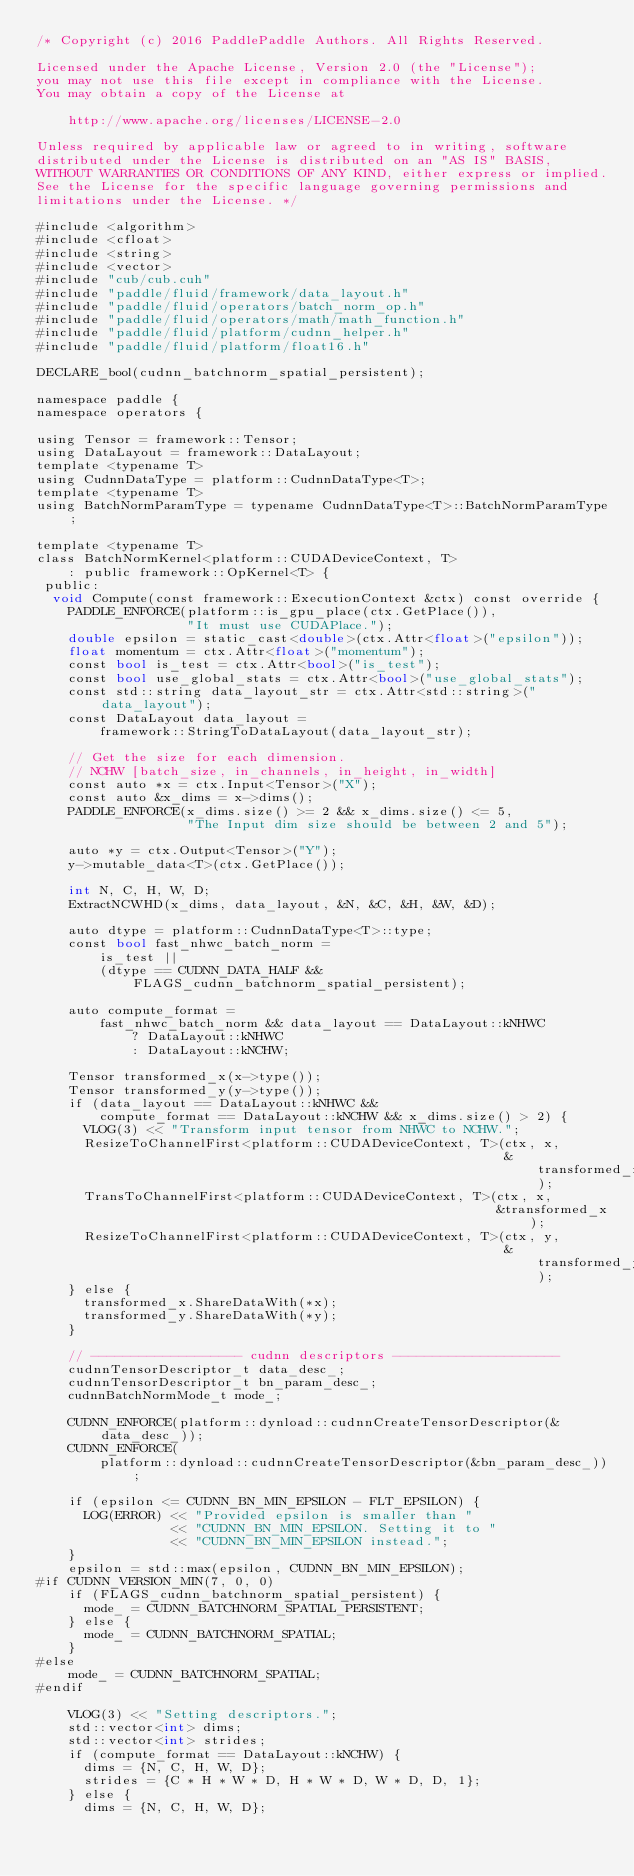<code> <loc_0><loc_0><loc_500><loc_500><_Cuda_>/* Copyright (c) 2016 PaddlePaddle Authors. All Rights Reserved.

Licensed under the Apache License, Version 2.0 (the "License");
you may not use this file except in compliance with the License.
You may obtain a copy of the License at

    http://www.apache.org/licenses/LICENSE-2.0

Unless required by applicable law or agreed to in writing, software
distributed under the License is distributed on an "AS IS" BASIS,
WITHOUT WARRANTIES OR CONDITIONS OF ANY KIND, either express or implied.
See the License for the specific language governing permissions and
limitations under the License. */

#include <algorithm>
#include <cfloat>
#include <string>
#include <vector>
#include "cub/cub.cuh"
#include "paddle/fluid/framework/data_layout.h"
#include "paddle/fluid/operators/batch_norm_op.h"
#include "paddle/fluid/operators/math/math_function.h"
#include "paddle/fluid/platform/cudnn_helper.h"
#include "paddle/fluid/platform/float16.h"

DECLARE_bool(cudnn_batchnorm_spatial_persistent);

namespace paddle {
namespace operators {

using Tensor = framework::Tensor;
using DataLayout = framework::DataLayout;
template <typename T>
using CudnnDataType = platform::CudnnDataType<T>;
template <typename T>
using BatchNormParamType = typename CudnnDataType<T>::BatchNormParamType;

template <typename T>
class BatchNormKernel<platform::CUDADeviceContext, T>
    : public framework::OpKernel<T> {
 public:
  void Compute(const framework::ExecutionContext &ctx) const override {
    PADDLE_ENFORCE(platform::is_gpu_place(ctx.GetPlace()),
                   "It must use CUDAPlace.");
    double epsilon = static_cast<double>(ctx.Attr<float>("epsilon"));
    float momentum = ctx.Attr<float>("momentum");
    const bool is_test = ctx.Attr<bool>("is_test");
    const bool use_global_stats = ctx.Attr<bool>("use_global_stats");
    const std::string data_layout_str = ctx.Attr<std::string>("data_layout");
    const DataLayout data_layout =
        framework::StringToDataLayout(data_layout_str);

    // Get the size for each dimension.
    // NCHW [batch_size, in_channels, in_height, in_width]
    const auto *x = ctx.Input<Tensor>("X");
    const auto &x_dims = x->dims();
    PADDLE_ENFORCE(x_dims.size() >= 2 && x_dims.size() <= 5,
                   "The Input dim size should be between 2 and 5");

    auto *y = ctx.Output<Tensor>("Y");
    y->mutable_data<T>(ctx.GetPlace());

    int N, C, H, W, D;
    ExtractNCWHD(x_dims, data_layout, &N, &C, &H, &W, &D);

    auto dtype = platform::CudnnDataType<T>::type;
    const bool fast_nhwc_batch_norm =
        is_test ||
        (dtype == CUDNN_DATA_HALF && FLAGS_cudnn_batchnorm_spatial_persistent);

    auto compute_format =
        fast_nhwc_batch_norm && data_layout == DataLayout::kNHWC
            ? DataLayout::kNHWC
            : DataLayout::kNCHW;

    Tensor transformed_x(x->type());
    Tensor transformed_y(y->type());
    if (data_layout == DataLayout::kNHWC &&
        compute_format == DataLayout::kNCHW && x_dims.size() > 2) {
      VLOG(3) << "Transform input tensor from NHWC to NCHW.";
      ResizeToChannelFirst<platform::CUDADeviceContext, T>(ctx, x,
                                                           &transformed_x);
      TransToChannelFirst<platform::CUDADeviceContext, T>(ctx, x,
                                                          &transformed_x);
      ResizeToChannelFirst<platform::CUDADeviceContext, T>(ctx, y,
                                                           &transformed_y);
    } else {
      transformed_x.ShareDataWith(*x);
      transformed_y.ShareDataWith(*y);
    }

    // ------------------- cudnn descriptors ---------------------
    cudnnTensorDescriptor_t data_desc_;
    cudnnTensorDescriptor_t bn_param_desc_;
    cudnnBatchNormMode_t mode_;

    CUDNN_ENFORCE(platform::dynload::cudnnCreateTensorDescriptor(&data_desc_));
    CUDNN_ENFORCE(
        platform::dynload::cudnnCreateTensorDescriptor(&bn_param_desc_));

    if (epsilon <= CUDNN_BN_MIN_EPSILON - FLT_EPSILON) {
      LOG(ERROR) << "Provided epsilon is smaller than "
                 << "CUDNN_BN_MIN_EPSILON. Setting it to "
                 << "CUDNN_BN_MIN_EPSILON instead.";
    }
    epsilon = std::max(epsilon, CUDNN_BN_MIN_EPSILON);
#if CUDNN_VERSION_MIN(7, 0, 0)
    if (FLAGS_cudnn_batchnorm_spatial_persistent) {
      mode_ = CUDNN_BATCHNORM_SPATIAL_PERSISTENT;
    } else {
      mode_ = CUDNN_BATCHNORM_SPATIAL;
    }
#else
    mode_ = CUDNN_BATCHNORM_SPATIAL;
#endif

    VLOG(3) << "Setting descriptors.";
    std::vector<int> dims;
    std::vector<int> strides;
    if (compute_format == DataLayout::kNCHW) {
      dims = {N, C, H, W, D};
      strides = {C * H * W * D, H * W * D, W * D, D, 1};
    } else {
      dims = {N, C, H, W, D};</code> 